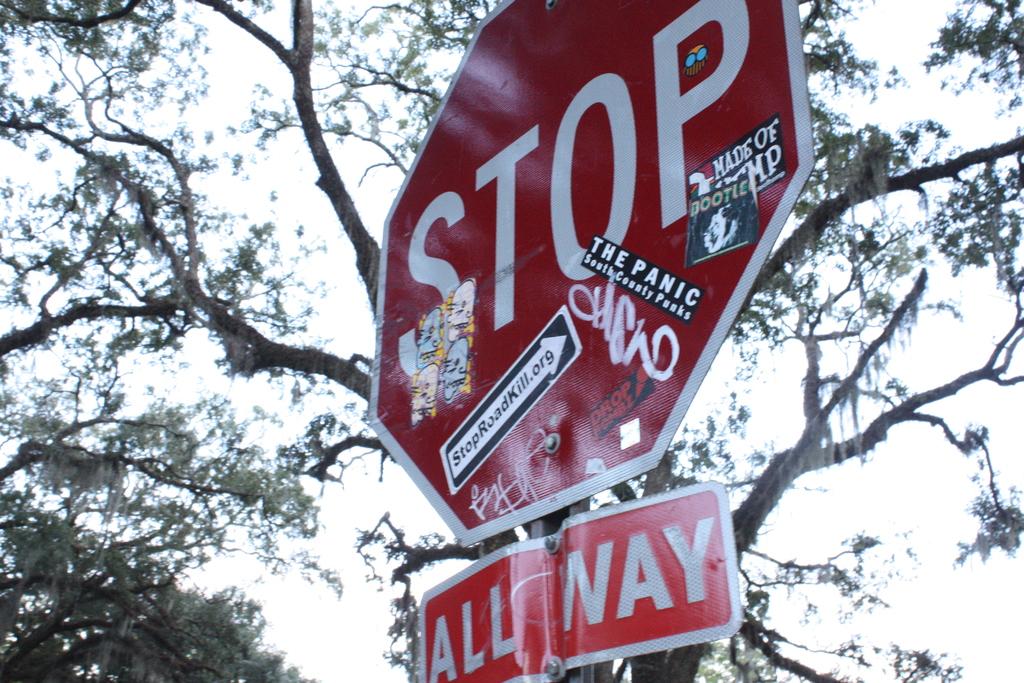What does the square sign say?
Offer a very short reply. All way. What website is stuck onto the sign?
Provide a succinct answer. Stoproadkill.org. 